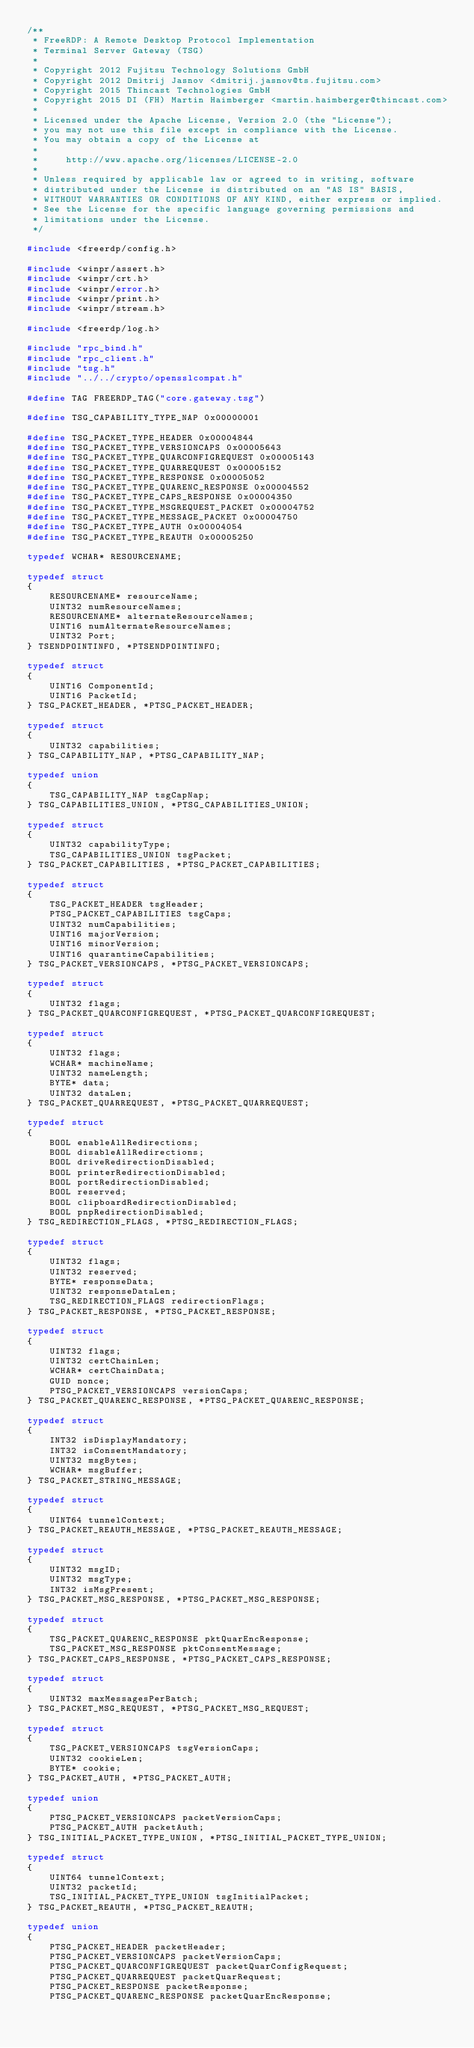<code> <loc_0><loc_0><loc_500><loc_500><_C_>/**
 * FreeRDP: A Remote Desktop Protocol Implementation
 * Terminal Server Gateway (TSG)
 *
 * Copyright 2012 Fujitsu Technology Solutions GmbH
 * Copyright 2012 Dmitrij Jasnov <dmitrij.jasnov@ts.fujitsu.com>
 * Copyright 2015 Thincast Technologies GmbH
 * Copyright 2015 DI (FH) Martin Haimberger <martin.haimberger@thincast.com>
 *
 * Licensed under the Apache License, Version 2.0 (the "License");
 * you may not use this file except in compliance with the License.
 * You may obtain a copy of the License at
 *
 *     http://www.apache.org/licenses/LICENSE-2.0
 *
 * Unless required by applicable law or agreed to in writing, software
 * distributed under the License is distributed on an "AS IS" BASIS,
 * WITHOUT WARRANTIES OR CONDITIONS OF ANY KIND, either express or implied.
 * See the License for the specific language governing permissions and
 * limitations under the License.
 */

#include <freerdp/config.h>

#include <winpr/assert.h>
#include <winpr/crt.h>
#include <winpr/error.h>
#include <winpr/print.h>
#include <winpr/stream.h>

#include <freerdp/log.h>

#include "rpc_bind.h"
#include "rpc_client.h"
#include "tsg.h"
#include "../../crypto/opensslcompat.h"

#define TAG FREERDP_TAG("core.gateway.tsg")

#define TSG_CAPABILITY_TYPE_NAP 0x00000001

#define TSG_PACKET_TYPE_HEADER 0x00004844
#define TSG_PACKET_TYPE_VERSIONCAPS 0x00005643
#define TSG_PACKET_TYPE_QUARCONFIGREQUEST 0x00005143
#define TSG_PACKET_TYPE_QUARREQUEST 0x00005152
#define TSG_PACKET_TYPE_RESPONSE 0x00005052
#define TSG_PACKET_TYPE_QUARENC_RESPONSE 0x00004552
#define TSG_PACKET_TYPE_CAPS_RESPONSE 0x00004350
#define TSG_PACKET_TYPE_MSGREQUEST_PACKET 0x00004752
#define TSG_PACKET_TYPE_MESSAGE_PACKET 0x00004750
#define TSG_PACKET_TYPE_AUTH 0x00004054
#define TSG_PACKET_TYPE_REAUTH 0x00005250

typedef WCHAR* RESOURCENAME;

typedef struct
{
	RESOURCENAME* resourceName;
	UINT32 numResourceNames;
	RESOURCENAME* alternateResourceNames;
	UINT16 numAlternateResourceNames;
	UINT32 Port;
} TSENDPOINTINFO, *PTSENDPOINTINFO;

typedef struct
{
	UINT16 ComponentId;
	UINT16 PacketId;
} TSG_PACKET_HEADER, *PTSG_PACKET_HEADER;

typedef struct
{
	UINT32 capabilities;
} TSG_CAPABILITY_NAP, *PTSG_CAPABILITY_NAP;

typedef union
{
	TSG_CAPABILITY_NAP tsgCapNap;
} TSG_CAPABILITIES_UNION, *PTSG_CAPABILITIES_UNION;

typedef struct
{
	UINT32 capabilityType;
	TSG_CAPABILITIES_UNION tsgPacket;
} TSG_PACKET_CAPABILITIES, *PTSG_PACKET_CAPABILITIES;

typedef struct
{
	TSG_PACKET_HEADER tsgHeader;
	PTSG_PACKET_CAPABILITIES tsgCaps;
	UINT32 numCapabilities;
	UINT16 majorVersion;
	UINT16 minorVersion;
	UINT16 quarantineCapabilities;
} TSG_PACKET_VERSIONCAPS, *PTSG_PACKET_VERSIONCAPS;

typedef struct
{
	UINT32 flags;
} TSG_PACKET_QUARCONFIGREQUEST, *PTSG_PACKET_QUARCONFIGREQUEST;

typedef struct
{
	UINT32 flags;
	WCHAR* machineName;
	UINT32 nameLength;
	BYTE* data;
	UINT32 dataLen;
} TSG_PACKET_QUARREQUEST, *PTSG_PACKET_QUARREQUEST;

typedef struct
{
	BOOL enableAllRedirections;
	BOOL disableAllRedirections;
	BOOL driveRedirectionDisabled;
	BOOL printerRedirectionDisabled;
	BOOL portRedirectionDisabled;
	BOOL reserved;
	BOOL clipboardRedirectionDisabled;
	BOOL pnpRedirectionDisabled;
} TSG_REDIRECTION_FLAGS, *PTSG_REDIRECTION_FLAGS;

typedef struct
{
	UINT32 flags;
	UINT32 reserved;
	BYTE* responseData;
	UINT32 responseDataLen;
	TSG_REDIRECTION_FLAGS redirectionFlags;
} TSG_PACKET_RESPONSE, *PTSG_PACKET_RESPONSE;

typedef struct
{
	UINT32 flags;
	UINT32 certChainLen;
	WCHAR* certChainData;
	GUID nonce;
	PTSG_PACKET_VERSIONCAPS versionCaps;
} TSG_PACKET_QUARENC_RESPONSE, *PTSG_PACKET_QUARENC_RESPONSE;

typedef struct
{
	INT32 isDisplayMandatory;
	INT32 isConsentMandatory;
	UINT32 msgBytes;
	WCHAR* msgBuffer;
} TSG_PACKET_STRING_MESSAGE;

typedef struct
{
	UINT64 tunnelContext;
} TSG_PACKET_REAUTH_MESSAGE, *PTSG_PACKET_REAUTH_MESSAGE;

typedef struct
{
	UINT32 msgID;
	UINT32 msgType;
	INT32 isMsgPresent;
} TSG_PACKET_MSG_RESPONSE, *PTSG_PACKET_MSG_RESPONSE;

typedef struct
{
	TSG_PACKET_QUARENC_RESPONSE pktQuarEncResponse;
	TSG_PACKET_MSG_RESPONSE pktConsentMessage;
} TSG_PACKET_CAPS_RESPONSE, *PTSG_PACKET_CAPS_RESPONSE;

typedef struct
{
	UINT32 maxMessagesPerBatch;
} TSG_PACKET_MSG_REQUEST, *PTSG_PACKET_MSG_REQUEST;

typedef struct
{
	TSG_PACKET_VERSIONCAPS tsgVersionCaps;
	UINT32 cookieLen;
	BYTE* cookie;
} TSG_PACKET_AUTH, *PTSG_PACKET_AUTH;

typedef union
{
	PTSG_PACKET_VERSIONCAPS packetVersionCaps;
	PTSG_PACKET_AUTH packetAuth;
} TSG_INITIAL_PACKET_TYPE_UNION, *PTSG_INITIAL_PACKET_TYPE_UNION;

typedef struct
{
	UINT64 tunnelContext;
	UINT32 packetId;
	TSG_INITIAL_PACKET_TYPE_UNION tsgInitialPacket;
} TSG_PACKET_REAUTH, *PTSG_PACKET_REAUTH;

typedef union
{
	PTSG_PACKET_HEADER packetHeader;
	PTSG_PACKET_VERSIONCAPS packetVersionCaps;
	PTSG_PACKET_QUARCONFIGREQUEST packetQuarConfigRequest;
	PTSG_PACKET_QUARREQUEST packetQuarRequest;
	PTSG_PACKET_RESPONSE packetResponse;
	PTSG_PACKET_QUARENC_RESPONSE packetQuarEncResponse;</code> 